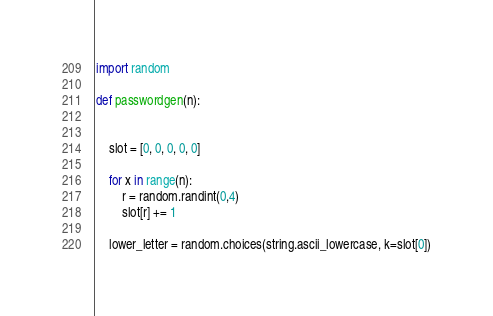<code> <loc_0><loc_0><loc_500><loc_500><_Python_>import random

def passwordgen(n):

    
    slot = [0, 0, 0, 0, 0]
    
    for x in range(n):
        r = random.randint(0,4)
        slot[r] += 1
    
    lower_letter = random.choices(string.ascii_lowercase, k=slot[0])</code> 